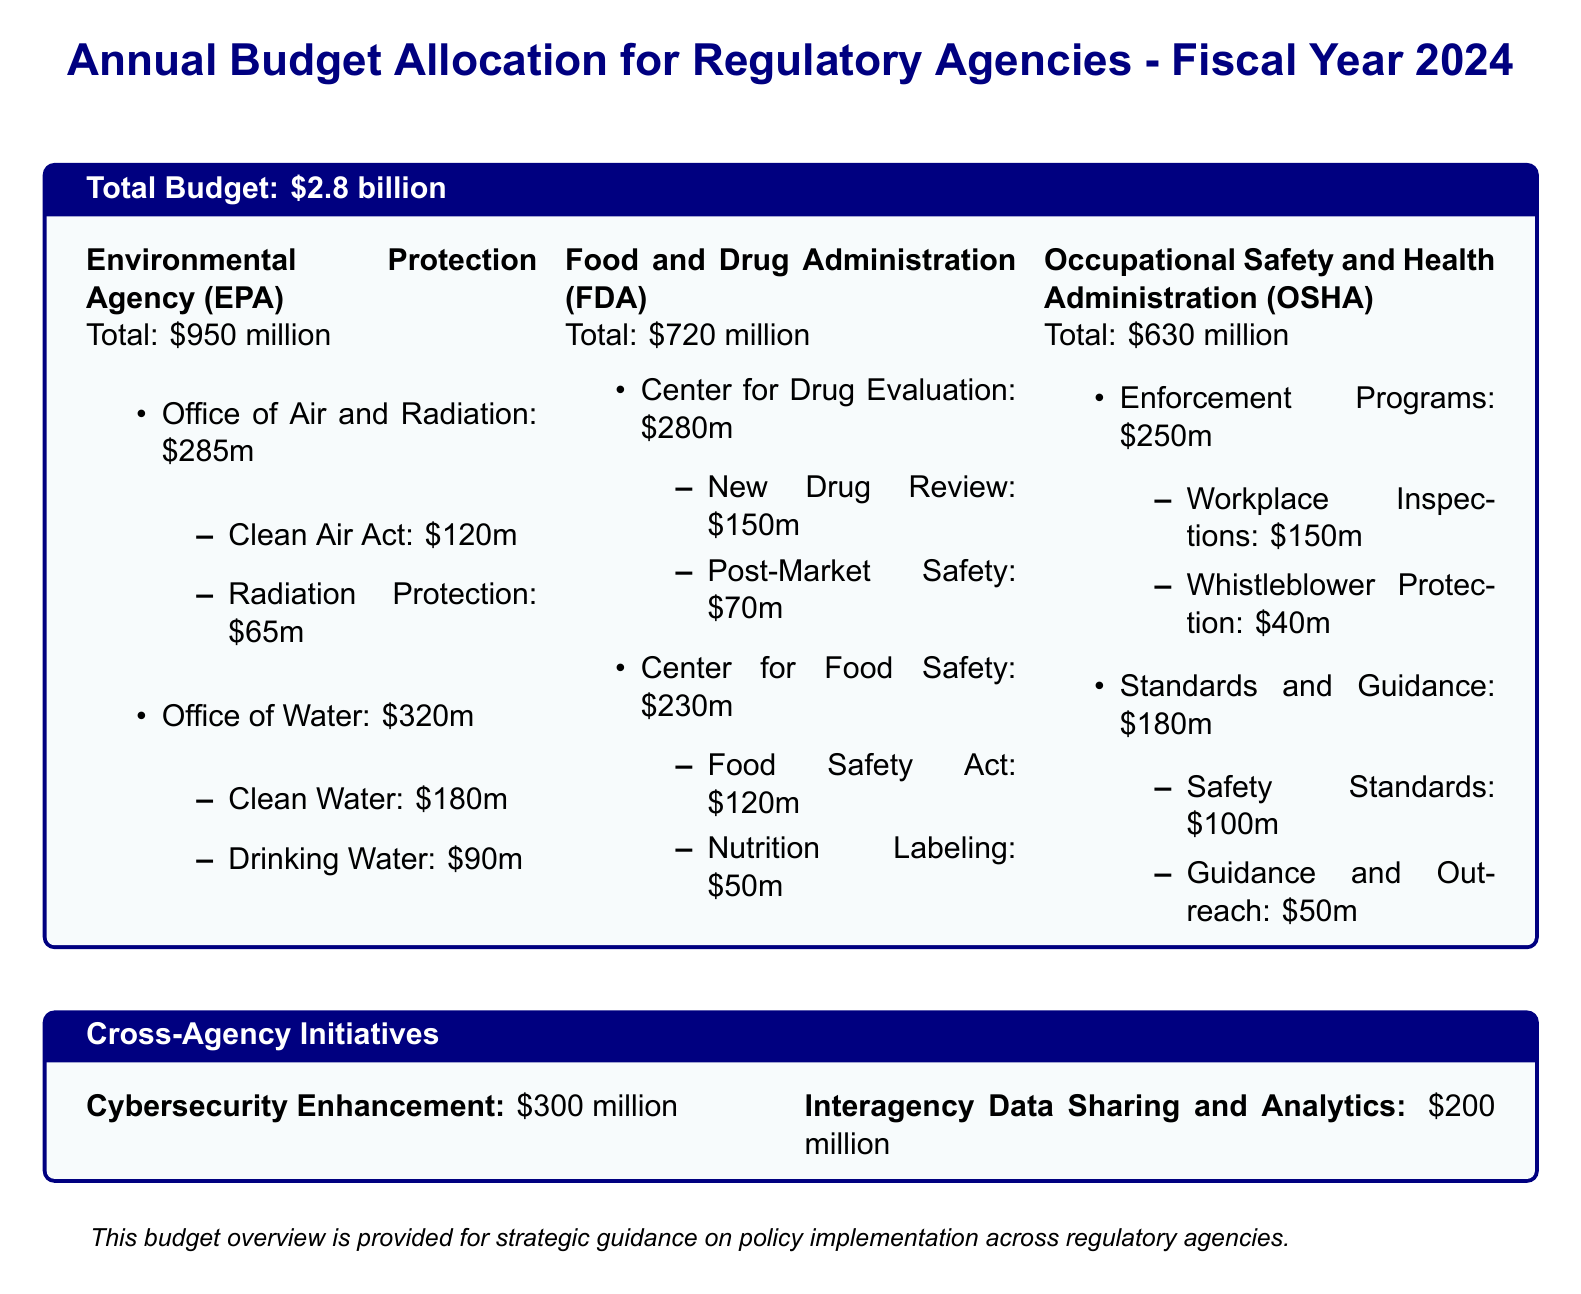What is the total budget allocation for regulatory agencies? The total budget allocation is specifically stated in the document as $2.8 billion.
Answer: $2.8 billion How much is allocated to the Environmental Protection Agency? The document clearly lists the total budget for the Environmental Protection Agency as $950 million.
Answer: $950 million What is the budget for the Office of Water within the EPA? The document provides a specific allocation of $320 million to the Office of Water under the EPA.
Answer: $320 million How much funding is earmarked for the Center for Food Safety at the FDA? The allocation for the Center for Food Safety is detailed in the document and amounts to $230 million.
Answer: $230 million What is the total amount allocated for Cybersecurity Enhancement? The document specifies that $300 million is allocated for Cybersecurity Enhancement.
Answer: $300 million Which program under OSHA has the highest budget? By analyzing the allocations, the program with the highest budget under OSHA is Enforcement Programs with $250 million.
Answer: Enforcement Programs What is the combined budget for the Clean Air Act and Radiation Protection? The document indicates the Clean Air Act has $120 million and Radiation Protection has $65 million, summing to $185 million.
Answer: $185 million How much is budgeted for Interagency Data Sharing and Analytics? The document lists the budget for Interagency Data Sharing and Analytics as $200 million.
Answer: $200 million What is the total budget allocated for the Office of Air and Radiation? The total budget for the Office of Air and Radiation is explicitly mentioned in the document as $285 million.
Answer: $285 million 